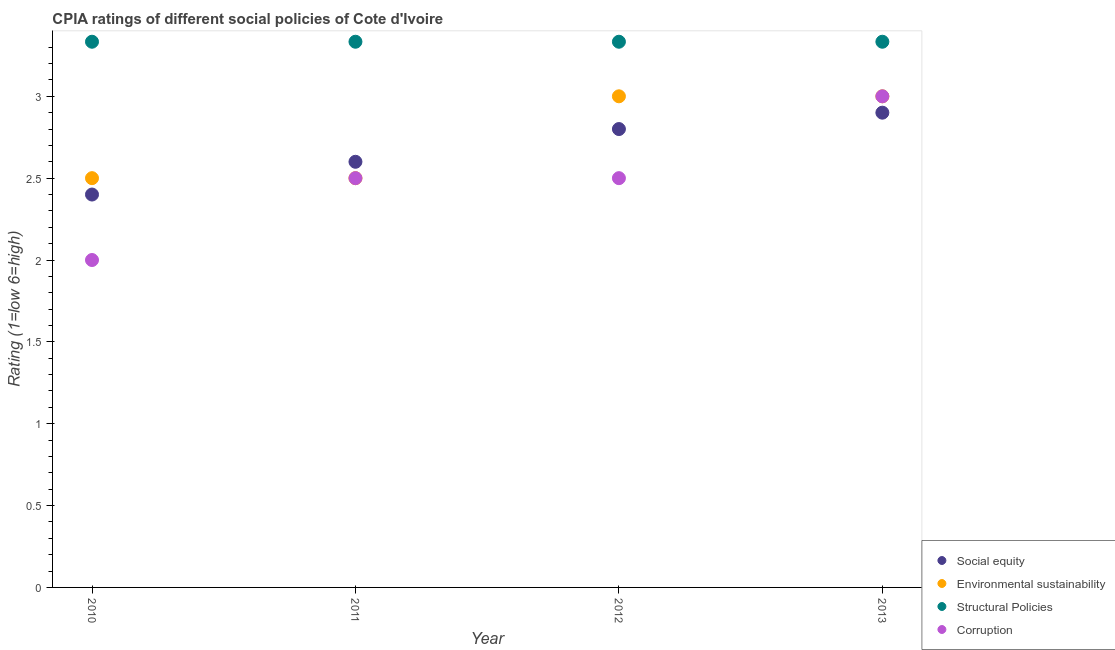What is the cpia rating of social equity in 2013?
Ensure brevity in your answer.  2.9. Across all years, what is the maximum cpia rating of social equity?
Ensure brevity in your answer.  2.9. In which year was the cpia rating of structural policies minimum?
Keep it short and to the point. 2010. What is the total cpia rating of social equity in the graph?
Offer a very short reply. 10.7. What is the average cpia rating of environmental sustainability per year?
Give a very brief answer. 2.75. In the year 2011, what is the difference between the cpia rating of structural policies and cpia rating of social equity?
Make the answer very short. 0.73. In how many years, is the cpia rating of environmental sustainability greater than 2.5?
Ensure brevity in your answer.  2. What is the ratio of the cpia rating of structural policies in 2011 to that in 2013?
Keep it short and to the point. 1. Is the cpia rating of environmental sustainability in 2011 less than that in 2012?
Your response must be concise. Yes. Is the difference between the cpia rating of structural policies in 2010 and 2011 greater than the difference between the cpia rating of environmental sustainability in 2010 and 2011?
Ensure brevity in your answer.  No. What is the difference between the highest and the second highest cpia rating of structural policies?
Your response must be concise. 0. What is the difference between the highest and the lowest cpia rating of environmental sustainability?
Ensure brevity in your answer.  0.5. In how many years, is the cpia rating of environmental sustainability greater than the average cpia rating of environmental sustainability taken over all years?
Give a very brief answer. 2. Is the sum of the cpia rating of corruption in 2010 and 2012 greater than the maximum cpia rating of structural policies across all years?
Provide a short and direct response. Yes. Is the cpia rating of environmental sustainability strictly greater than the cpia rating of corruption over the years?
Ensure brevity in your answer.  No. How many years are there in the graph?
Offer a terse response. 4. Where does the legend appear in the graph?
Give a very brief answer. Bottom right. How many legend labels are there?
Your answer should be compact. 4. How are the legend labels stacked?
Make the answer very short. Vertical. What is the title of the graph?
Provide a short and direct response. CPIA ratings of different social policies of Cote d'Ivoire. Does "Efficiency of custom clearance process" appear as one of the legend labels in the graph?
Offer a very short reply. No. What is the label or title of the X-axis?
Your response must be concise. Year. What is the Rating (1=low 6=high) in Environmental sustainability in 2010?
Provide a succinct answer. 2.5. What is the Rating (1=low 6=high) in Structural Policies in 2010?
Offer a terse response. 3.33. What is the Rating (1=low 6=high) of Social equity in 2011?
Keep it short and to the point. 2.6. What is the Rating (1=low 6=high) of Structural Policies in 2011?
Give a very brief answer. 3.33. What is the Rating (1=low 6=high) of Structural Policies in 2012?
Provide a succinct answer. 3.33. What is the Rating (1=low 6=high) of Corruption in 2012?
Give a very brief answer. 2.5. What is the Rating (1=low 6=high) of Environmental sustainability in 2013?
Offer a very short reply. 3. What is the Rating (1=low 6=high) in Structural Policies in 2013?
Provide a succinct answer. 3.33. Across all years, what is the maximum Rating (1=low 6=high) in Social equity?
Your answer should be very brief. 2.9. Across all years, what is the maximum Rating (1=low 6=high) in Structural Policies?
Provide a short and direct response. 3.33. Across all years, what is the maximum Rating (1=low 6=high) of Corruption?
Give a very brief answer. 3. Across all years, what is the minimum Rating (1=low 6=high) in Structural Policies?
Offer a very short reply. 3.33. What is the total Rating (1=low 6=high) of Structural Policies in the graph?
Your answer should be compact. 13.33. What is the difference between the Rating (1=low 6=high) of Social equity in 2010 and that in 2011?
Offer a very short reply. -0.2. What is the difference between the Rating (1=low 6=high) of Corruption in 2010 and that in 2011?
Offer a terse response. -0.5. What is the difference between the Rating (1=low 6=high) in Social equity in 2010 and that in 2012?
Offer a terse response. -0.4. What is the difference between the Rating (1=low 6=high) in Corruption in 2010 and that in 2012?
Your response must be concise. -0.5. What is the difference between the Rating (1=low 6=high) in Social equity in 2010 and that in 2013?
Give a very brief answer. -0.5. What is the difference between the Rating (1=low 6=high) in Environmental sustainability in 2010 and that in 2013?
Your answer should be compact. -0.5. What is the difference between the Rating (1=low 6=high) of Corruption in 2010 and that in 2013?
Your answer should be compact. -1. What is the difference between the Rating (1=low 6=high) of Social equity in 2011 and that in 2012?
Provide a short and direct response. -0.2. What is the difference between the Rating (1=low 6=high) in Environmental sustainability in 2011 and that in 2012?
Give a very brief answer. -0.5. What is the difference between the Rating (1=low 6=high) of Corruption in 2011 and that in 2012?
Your answer should be compact. 0. What is the difference between the Rating (1=low 6=high) of Social equity in 2011 and that in 2013?
Your answer should be compact. -0.3. What is the difference between the Rating (1=low 6=high) in Environmental sustainability in 2011 and that in 2013?
Give a very brief answer. -0.5. What is the difference between the Rating (1=low 6=high) of Structural Policies in 2011 and that in 2013?
Your response must be concise. 0. What is the difference between the Rating (1=low 6=high) of Corruption in 2011 and that in 2013?
Give a very brief answer. -0.5. What is the difference between the Rating (1=low 6=high) of Environmental sustainability in 2012 and that in 2013?
Offer a very short reply. 0. What is the difference between the Rating (1=low 6=high) of Structural Policies in 2012 and that in 2013?
Your answer should be very brief. 0. What is the difference between the Rating (1=low 6=high) in Social equity in 2010 and the Rating (1=low 6=high) in Structural Policies in 2011?
Give a very brief answer. -0.93. What is the difference between the Rating (1=low 6=high) of Environmental sustainability in 2010 and the Rating (1=low 6=high) of Corruption in 2011?
Make the answer very short. 0. What is the difference between the Rating (1=low 6=high) in Structural Policies in 2010 and the Rating (1=low 6=high) in Corruption in 2011?
Offer a terse response. 0.83. What is the difference between the Rating (1=low 6=high) in Social equity in 2010 and the Rating (1=low 6=high) in Structural Policies in 2012?
Your answer should be compact. -0.93. What is the difference between the Rating (1=low 6=high) of Social equity in 2010 and the Rating (1=low 6=high) of Corruption in 2012?
Offer a very short reply. -0.1. What is the difference between the Rating (1=low 6=high) in Environmental sustainability in 2010 and the Rating (1=low 6=high) in Corruption in 2012?
Ensure brevity in your answer.  0. What is the difference between the Rating (1=low 6=high) in Social equity in 2010 and the Rating (1=low 6=high) in Structural Policies in 2013?
Your answer should be compact. -0.93. What is the difference between the Rating (1=low 6=high) of Environmental sustainability in 2010 and the Rating (1=low 6=high) of Corruption in 2013?
Your answer should be compact. -0.5. What is the difference between the Rating (1=low 6=high) in Social equity in 2011 and the Rating (1=low 6=high) in Environmental sustainability in 2012?
Give a very brief answer. -0.4. What is the difference between the Rating (1=low 6=high) of Social equity in 2011 and the Rating (1=low 6=high) of Structural Policies in 2012?
Make the answer very short. -0.73. What is the difference between the Rating (1=low 6=high) of Social equity in 2011 and the Rating (1=low 6=high) of Corruption in 2012?
Your response must be concise. 0.1. What is the difference between the Rating (1=low 6=high) of Environmental sustainability in 2011 and the Rating (1=low 6=high) of Structural Policies in 2012?
Ensure brevity in your answer.  -0.83. What is the difference between the Rating (1=low 6=high) of Environmental sustainability in 2011 and the Rating (1=low 6=high) of Corruption in 2012?
Keep it short and to the point. 0. What is the difference between the Rating (1=low 6=high) in Social equity in 2011 and the Rating (1=low 6=high) in Environmental sustainability in 2013?
Offer a terse response. -0.4. What is the difference between the Rating (1=low 6=high) in Social equity in 2011 and the Rating (1=low 6=high) in Structural Policies in 2013?
Ensure brevity in your answer.  -0.73. What is the difference between the Rating (1=low 6=high) of Environmental sustainability in 2011 and the Rating (1=low 6=high) of Structural Policies in 2013?
Provide a short and direct response. -0.83. What is the difference between the Rating (1=low 6=high) in Social equity in 2012 and the Rating (1=low 6=high) in Structural Policies in 2013?
Your answer should be compact. -0.53. What is the difference between the Rating (1=low 6=high) in Structural Policies in 2012 and the Rating (1=low 6=high) in Corruption in 2013?
Ensure brevity in your answer.  0.33. What is the average Rating (1=low 6=high) of Social equity per year?
Offer a very short reply. 2.67. What is the average Rating (1=low 6=high) in Environmental sustainability per year?
Offer a very short reply. 2.75. In the year 2010, what is the difference between the Rating (1=low 6=high) of Social equity and Rating (1=low 6=high) of Environmental sustainability?
Offer a terse response. -0.1. In the year 2010, what is the difference between the Rating (1=low 6=high) in Social equity and Rating (1=low 6=high) in Structural Policies?
Provide a succinct answer. -0.93. In the year 2011, what is the difference between the Rating (1=low 6=high) of Social equity and Rating (1=low 6=high) of Environmental sustainability?
Your answer should be very brief. 0.1. In the year 2011, what is the difference between the Rating (1=low 6=high) of Social equity and Rating (1=low 6=high) of Structural Policies?
Offer a very short reply. -0.73. In the year 2011, what is the difference between the Rating (1=low 6=high) of Environmental sustainability and Rating (1=low 6=high) of Structural Policies?
Give a very brief answer. -0.83. In the year 2011, what is the difference between the Rating (1=low 6=high) of Environmental sustainability and Rating (1=low 6=high) of Corruption?
Give a very brief answer. 0. In the year 2011, what is the difference between the Rating (1=low 6=high) in Structural Policies and Rating (1=low 6=high) in Corruption?
Keep it short and to the point. 0.83. In the year 2012, what is the difference between the Rating (1=low 6=high) of Social equity and Rating (1=low 6=high) of Structural Policies?
Provide a short and direct response. -0.53. In the year 2012, what is the difference between the Rating (1=low 6=high) of Social equity and Rating (1=low 6=high) of Corruption?
Make the answer very short. 0.3. In the year 2012, what is the difference between the Rating (1=low 6=high) of Structural Policies and Rating (1=low 6=high) of Corruption?
Ensure brevity in your answer.  0.83. In the year 2013, what is the difference between the Rating (1=low 6=high) in Social equity and Rating (1=low 6=high) in Environmental sustainability?
Your answer should be very brief. -0.1. In the year 2013, what is the difference between the Rating (1=low 6=high) in Social equity and Rating (1=low 6=high) in Structural Policies?
Offer a terse response. -0.43. In the year 2013, what is the difference between the Rating (1=low 6=high) of Environmental sustainability and Rating (1=low 6=high) of Structural Policies?
Offer a very short reply. -0.33. What is the ratio of the Rating (1=low 6=high) in Social equity in 2010 to that in 2011?
Ensure brevity in your answer.  0.92. What is the ratio of the Rating (1=low 6=high) in Corruption in 2010 to that in 2012?
Provide a short and direct response. 0.8. What is the ratio of the Rating (1=low 6=high) in Social equity in 2010 to that in 2013?
Your answer should be very brief. 0.83. What is the ratio of the Rating (1=low 6=high) of Environmental sustainability in 2010 to that in 2013?
Provide a succinct answer. 0.83. What is the ratio of the Rating (1=low 6=high) in Environmental sustainability in 2011 to that in 2012?
Provide a short and direct response. 0.83. What is the ratio of the Rating (1=low 6=high) of Structural Policies in 2011 to that in 2012?
Your response must be concise. 1. What is the ratio of the Rating (1=low 6=high) in Social equity in 2011 to that in 2013?
Your answer should be compact. 0.9. What is the ratio of the Rating (1=low 6=high) of Social equity in 2012 to that in 2013?
Your response must be concise. 0.97. What is the difference between the highest and the second highest Rating (1=low 6=high) in Social equity?
Provide a succinct answer. 0.1. What is the difference between the highest and the second highest Rating (1=low 6=high) of Environmental sustainability?
Give a very brief answer. 0. What is the difference between the highest and the second highest Rating (1=low 6=high) of Structural Policies?
Give a very brief answer. 0. What is the difference between the highest and the second highest Rating (1=low 6=high) of Corruption?
Provide a succinct answer. 0.5. What is the difference between the highest and the lowest Rating (1=low 6=high) of Social equity?
Make the answer very short. 0.5. What is the difference between the highest and the lowest Rating (1=low 6=high) in Environmental sustainability?
Offer a very short reply. 0.5. What is the difference between the highest and the lowest Rating (1=low 6=high) in Structural Policies?
Ensure brevity in your answer.  0. 